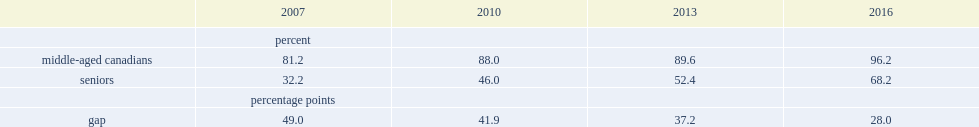How many percentage points was the absolute gap in internet use between non-seniors and seniors in 2007? 49.0. How many percentage points was the absolute gap in internet use between non-seniors and seniors in 2016? 28.0. How many percentage points did the gap between seniors and middle-aged canadians narrow from 2007 to 2016? 21. 